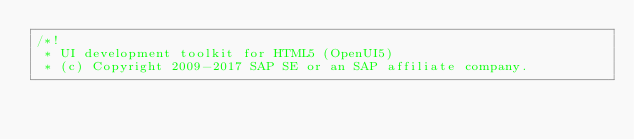<code> <loc_0><loc_0><loc_500><loc_500><_JavaScript_>/*!
 * UI development toolkit for HTML5 (OpenUI5)
 * (c) Copyright 2009-2017 SAP SE or an SAP affiliate company.</code> 